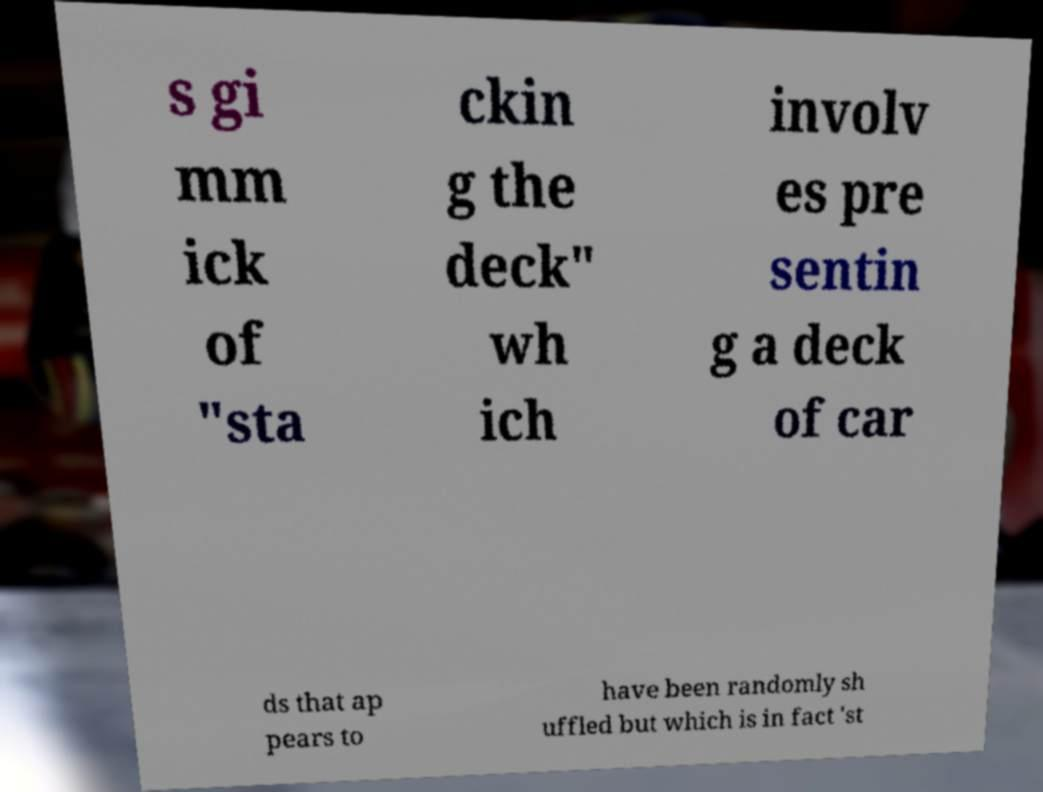Can you read and provide the text displayed in the image?This photo seems to have some interesting text. Can you extract and type it out for me? s gi mm ick of "sta ckin g the deck" wh ich involv es pre sentin g a deck of car ds that ap pears to have been randomly sh uffled but which is in fact 'st 